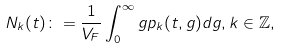Convert formula to latex. <formula><loc_0><loc_0><loc_500><loc_500>N _ { k } ( t ) \colon = \frac { 1 } { V _ { F } } \int _ { 0 } ^ { \infty } g p _ { k } ( t , g ) d g , k \in \mathbb { Z } ,</formula> 